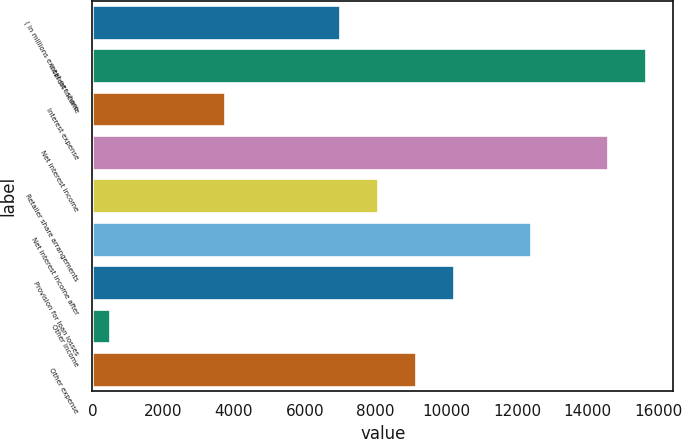Convert chart. <chart><loc_0><loc_0><loc_500><loc_500><bar_chart><fcel>( in millions except per share<fcel>Interest income<fcel>Interest expense<fcel>Net interest income<fcel>Retailer share arrangements<fcel>Net interest income after<fcel>Provision for loan losses<fcel>Other income<fcel>Other expense<nl><fcel>6987.8<fcel>15638.2<fcel>3743.9<fcel>14556.9<fcel>8069.1<fcel>12394.3<fcel>10231.7<fcel>500<fcel>9150.4<nl></chart> 